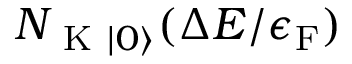Convert formula to latex. <formula><loc_0><loc_0><loc_500><loc_500>N _ { K | 0 \rangle } ( \Delta E / \epsilon _ { F } )</formula> 